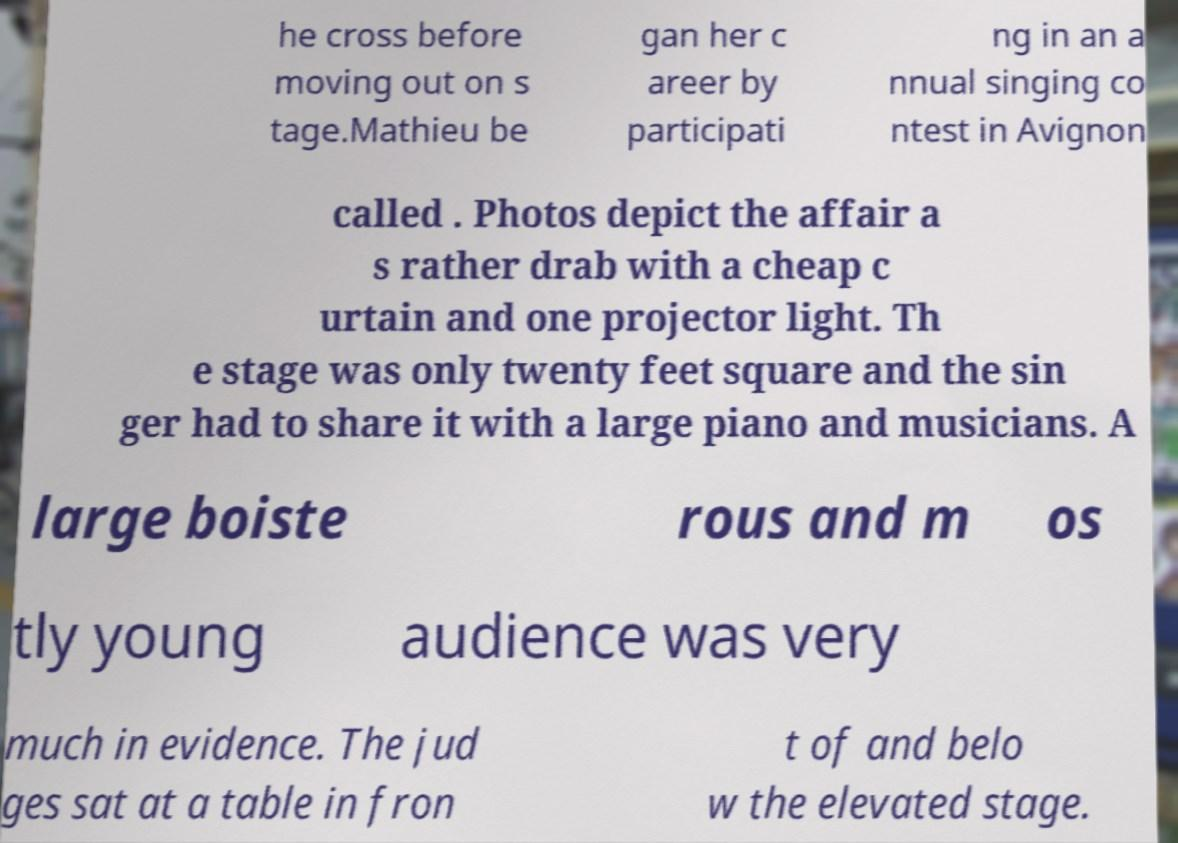I need the written content from this picture converted into text. Can you do that? he cross before moving out on s tage.Mathieu be gan her c areer by participati ng in an a nnual singing co ntest in Avignon called . Photos depict the affair a s rather drab with a cheap c urtain and one projector light. Th e stage was only twenty feet square and the sin ger had to share it with a large piano and musicians. A large boiste rous and m os tly young audience was very much in evidence. The jud ges sat at a table in fron t of and belo w the elevated stage. 